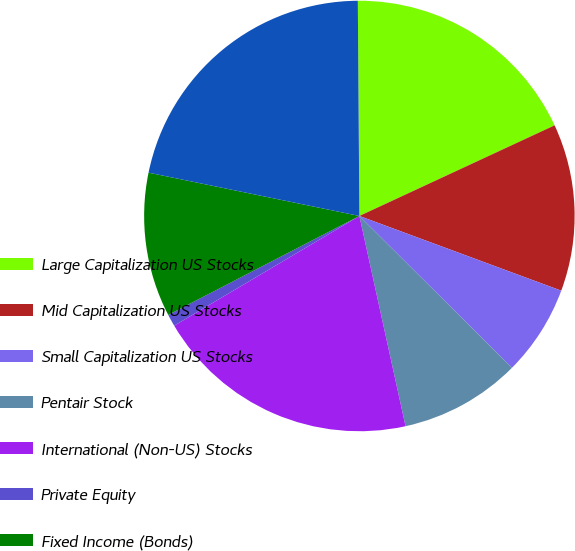<chart> <loc_0><loc_0><loc_500><loc_500><pie_chart><fcel>Large Capitalization US Stocks<fcel>Mid Capitalization US Stocks<fcel>Small Capitalization US Stocks<fcel>Pentair Stock<fcel>International (Non-US) Stocks<fcel>Private Equity<fcel>Fixed Income (Bonds)<fcel>Fund of Hedged Funds<nl><fcel>18.2%<fcel>12.56%<fcel>6.82%<fcel>9.1%<fcel>19.93%<fcel>0.91%<fcel>10.83%<fcel>21.66%<nl></chart> 